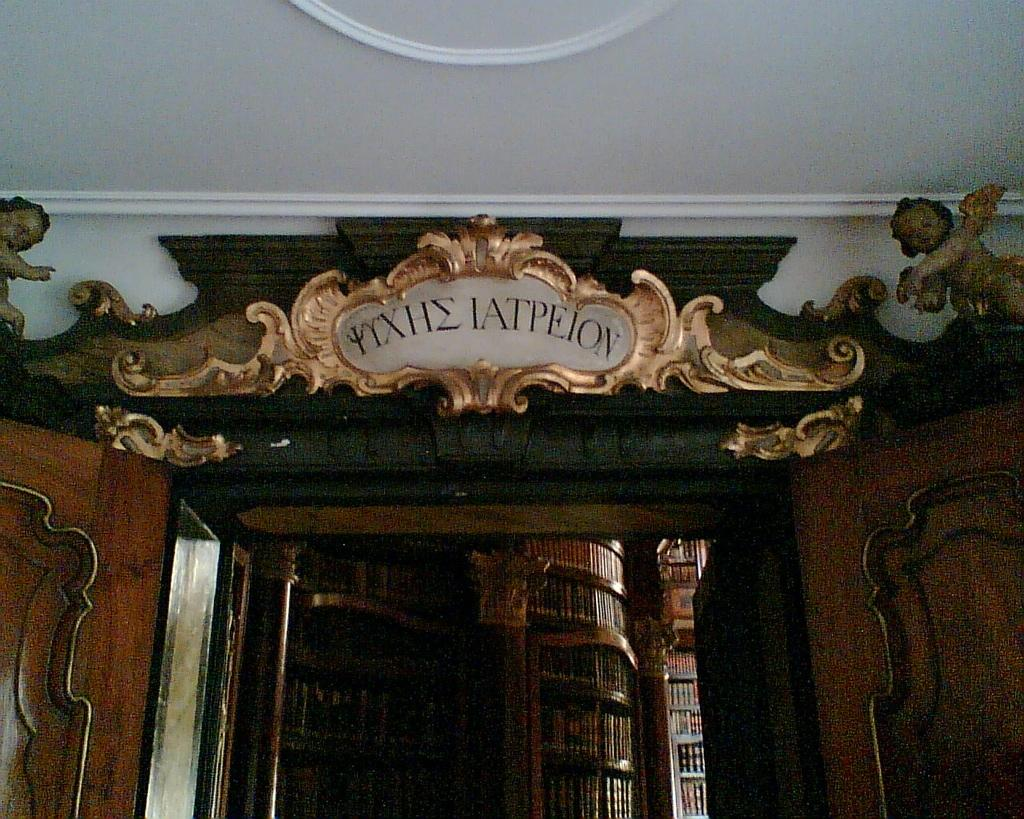What is the main subject of the image? The image is a zoomed in picture of an entrance. What feature of the entrance is visible in the image? The entrance has doors. What can be seen behind the doors in the image? There is a rack with books behind the doors. What part of the room is visible at the top of the image? The ceiling is visible at the top of the image. Can you see a monkey wearing a crown in the image? No, there is no monkey or crown present in the image. What is the wish of the person standing behind the doors in the image? There is no person standing behind the doors in the image, so it is impossible to determine their wish. 